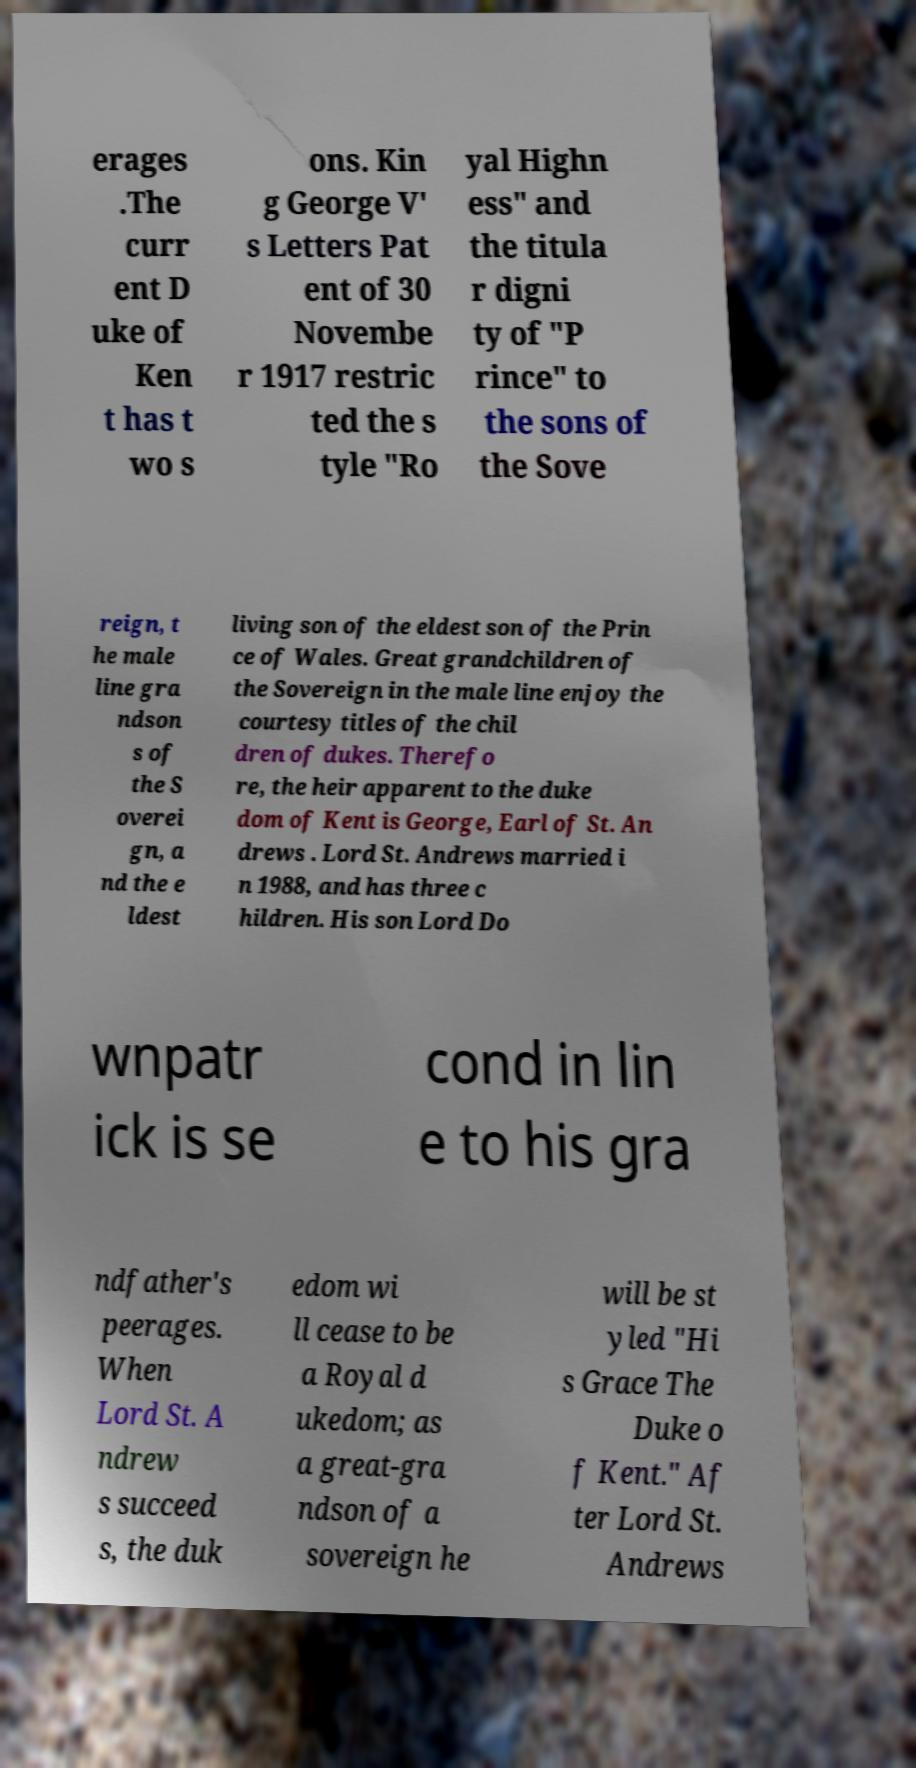I need the written content from this picture converted into text. Can you do that? erages .The curr ent D uke of Ken t has t wo s ons. Kin g George V' s Letters Pat ent of 30 Novembe r 1917 restric ted the s tyle "Ro yal Highn ess" and the titula r digni ty of "P rince" to the sons of the Sove reign, t he male line gra ndson s of the S overei gn, a nd the e ldest living son of the eldest son of the Prin ce of Wales. Great grandchildren of the Sovereign in the male line enjoy the courtesy titles of the chil dren of dukes. Therefo re, the heir apparent to the duke dom of Kent is George, Earl of St. An drews . Lord St. Andrews married i n 1988, and has three c hildren. His son Lord Do wnpatr ick is se cond in lin e to his gra ndfather's peerages. When Lord St. A ndrew s succeed s, the duk edom wi ll cease to be a Royal d ukedom; as a great-gra ndson of a sovereign he will be st yled "Hi s Grace The Duke o f Kent." Af ter Lord St. Andrews 